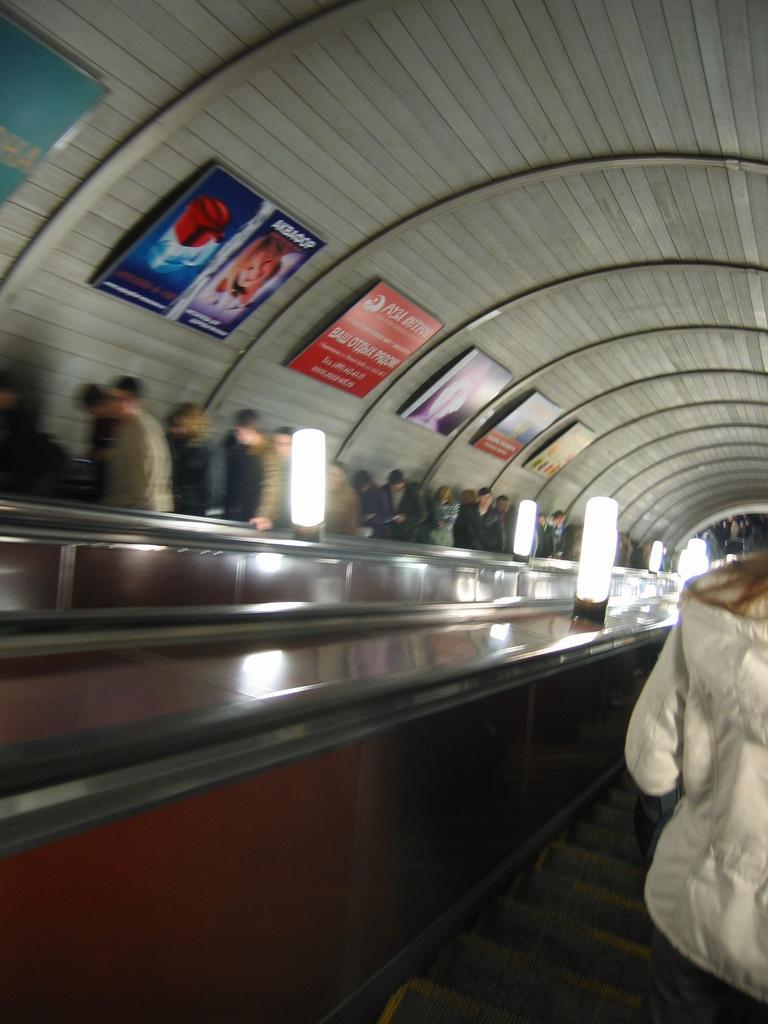In one or two sentences, can you explain what this image depicts? On the right side, there is a person. Beside this person, there are lights arranged. In the background, there are persons and there are posters attached to the roof. 